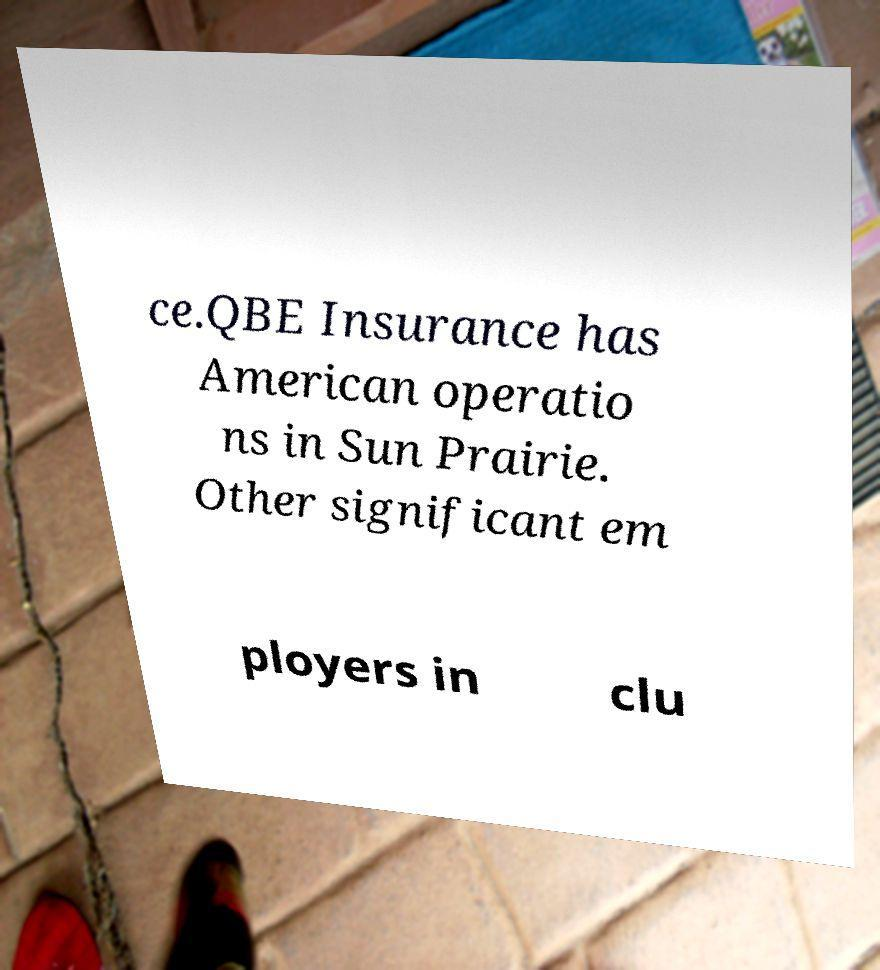I need the written content from this picture converted into text. Can you do that? ce.QBE Insurance has American operatio ns in Sun Prairie. Other significant em ployers in clu 